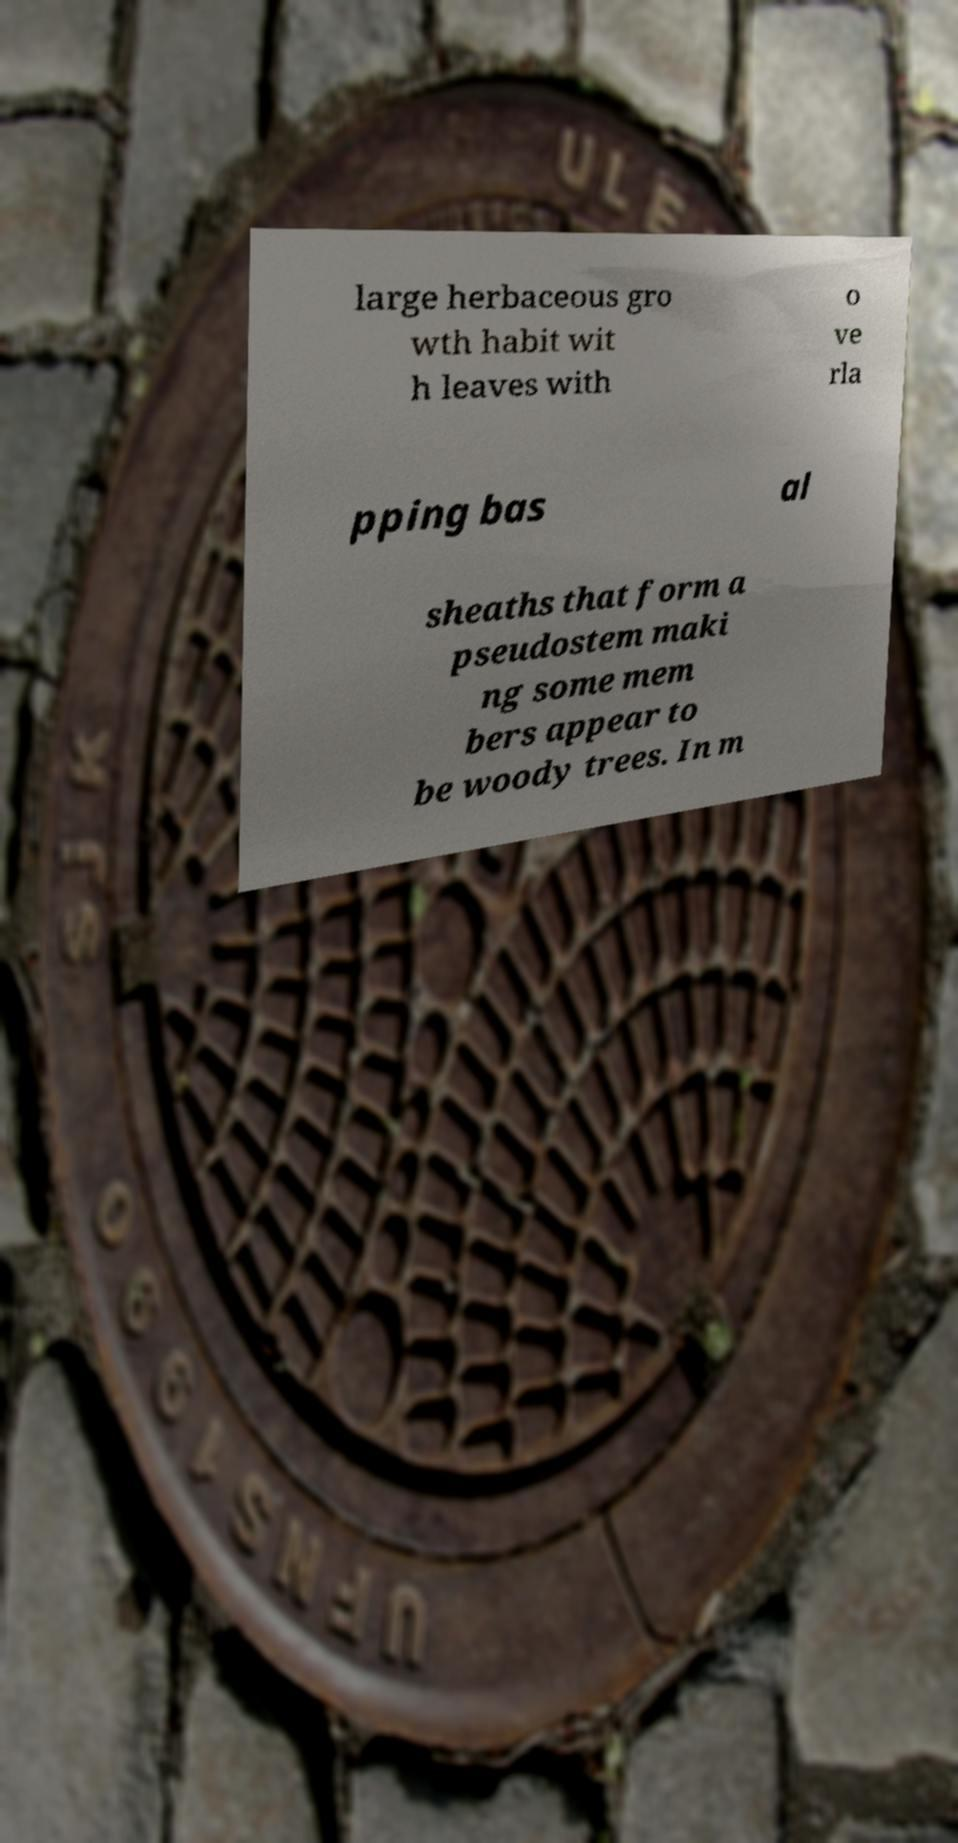I need the written content from this picture converted into text. Can you do that? large herbaceous gro wth habit wit h leaves with o ve rla pping bas al sheaths that form a pseudostem maki ng some mem bers appear to be woody trees. In m 